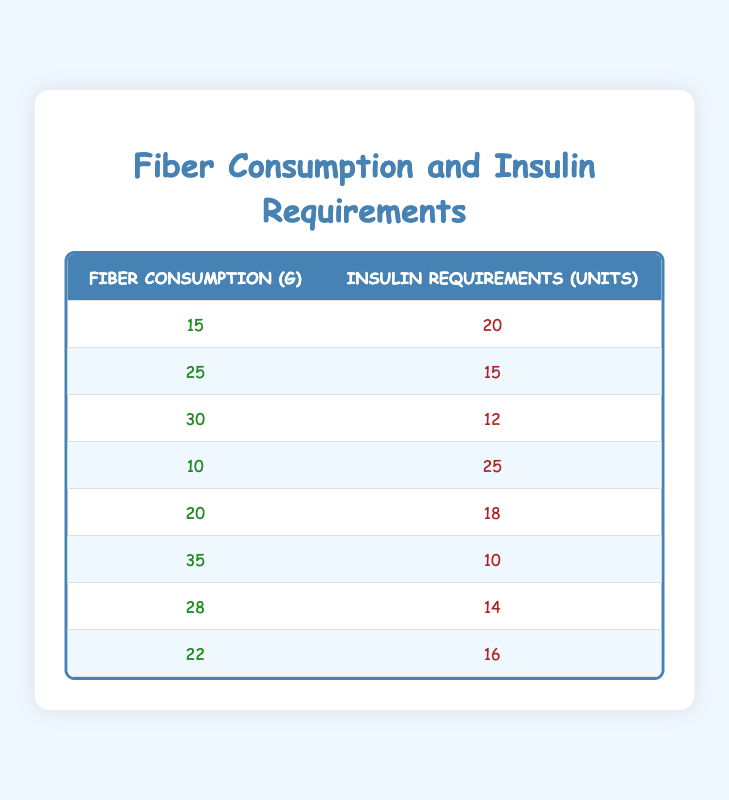What is the insulin requirement when the fiber consumption is 15 grams? According to the table, when fiber consumption is 15 grams, the corresponding insulin requirement is 20 units.
Answer: 20 units What is the fiber consumption associated with the lowest insulin requirement? The lowest insulin requirement listed in the table is 10 units, which corresponds to a fiber consumption of 35 grams.
Answer: 35 grams Is it true that increased fiber consumption generally leads to lower insulin requirements? Looking at the table, when fiber consumption increases (from 15 to 35 grams), insulin requirements decrease from 20 units to 10 units. Thus, it suggests a general trend where higher fiber intake is associated with lower insulin needs. Therefore, the statement is true.
Answer: Yes What is the sum of insulin requirements for fiber consumptions of 20 grams and 30 grams? From the table, the insulin requirement at 20 grams of fiber is 18 units and at 30 grams is 12 units. Adding these gives: 18 + 12 = 30 units.
Answer: 30 units What is the average fiber consumption for all the entries in the table? First, add all the fiber consumption values: 15 + 25 + 30 + 10 + 20 + 35 + 28 + 22 =  165 grams. Then, divide by the number of entries (8) to get the average: 165 / 8 = 20.625 grams. Therefore, the average fiber consumption is approximately 20.63 grams.
Answer: 20.63 grams How many insulin units are needed in total for fiber consumptions of 10 grams and 22 grams? From the table, the insulin requirement for 10 grams is 25 units and for 22 grams is 16 units. Adding these two values gives: 25 + 16 = 41 units.
Answer: 41 units Is there a fiber consumption value for which the insulin requirement is equal to 14 units? By checking the insulin requirements in the table, we see that an insulin requirement of 14 units corresponds to a fiber consumption of 28 grams. Hence, there is such a value.
Answer: Yes What is the difference in insulin requirements between the highest and lowest fiber consumption values? The highest fiber consumption is 35 grams (10 units insulin), and the lowest is 10 grams (25 units insulin). The difference in insulin requirements is: 25 - 10 = 15 units.
Answer: 15 units 